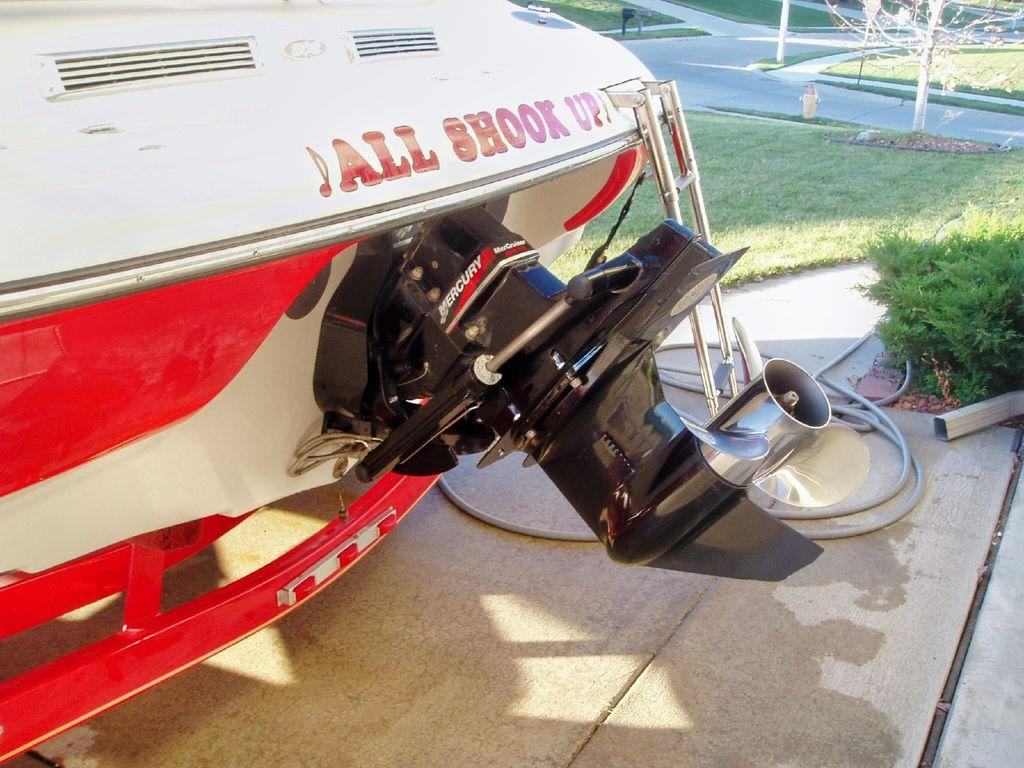What is the main object in the image? There is a pole in the image. What type of natural environment is depicted in the image? The image contains grass, trees, and small plants. What colors are used for the aircraft in the image? The aircraft is in red, white, and black colors. How does the mist affect the visibility of the doll in the image? There is no mist or doll present in the image. 